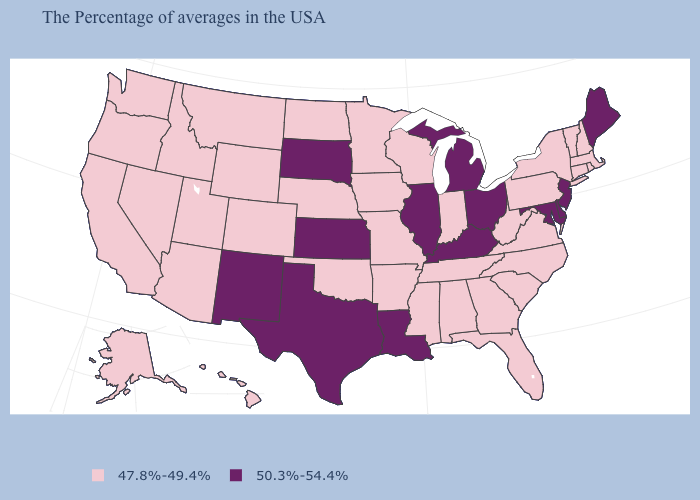Does Alaska have the same value as Michigan?
Concise answer only. No. What is the value of Idaho?
Give a very brief answer. 47.8%-49.4%. Name the states that have a value in the range 47.8%-49.4%?
Answer briefly. Massachusetts, Rhode Island, New Hampshire, Vermont, Connecticut, New York, Pennsylvania, Virginia, North Carolina, South Carolina, West Virginia, Florida, Georgia, Indiana, Alabama, Tennessee, Wisconsin, Mississippi, Missouri, Arkansas, Minnesota, Iowa, Nebraska, Oklahoma, North Dakota, Wyoming, Colorado, Utah, Montana, Arizona, Idaho, Nevada, California, Washington, Oregon, Alaska, Hawaii. Name the states that have a value in the range 50.3%-54.4%?
Keep it brief. Maine, New Jersey, Delaware, Maryland, Ohio, Michigan, Kentucky, Illinois, Louisiana, Kansas, Texas, South Dakota, New Mexico. Name the states that have a value in the range 50.3%-54.4%?
Be succinct. Maine, New Jersey, Delaware, Maryland, Ohio, Michigan, Kentucky, Illinois, Louisiana, Kansas, Texas, South Dakota, New Mexico. What is the value of West Virginia?
Quick response, please. 47.8%-49.4%. What is the highest value in the South ?
Answer briefly. 50.3%-54.4%. What is the value of Oklahoma?
Short answer required. 47.8%-49.4%. Which states have the highest value in the USA?
Give a very brief answer. Maine, New Jersey, Delaware, Maryland, Ohio, Michigan, Kentucky, Illinois, Louisiana, Kansas, Texas, South Dakota, New Mexico. Does Kentucky have the highest value in the USA?
Short answer required. Yes. Among the states that border New Mexico , does Colorado have the highest value?
Short answer required. No. What is the value of New Mexico?
Concise answer only. 50.3%-54.4%. Does New Jersey have the highest value in the USA?
Give a very brief answer. Yes. What is the lowest value in the USA?
Concise answer only. 47.8%-49.4%. 